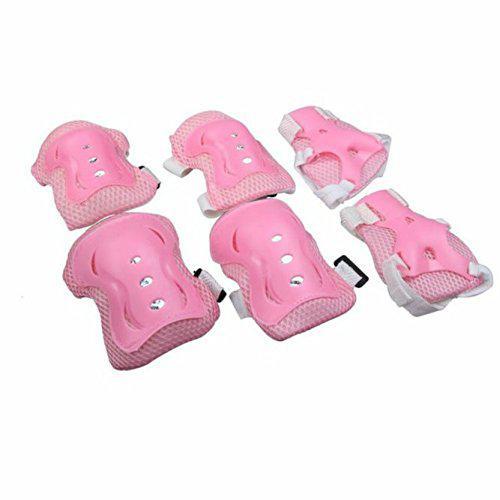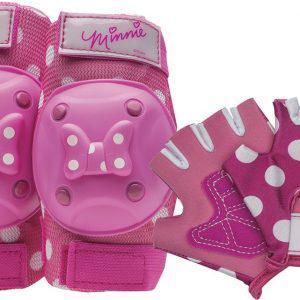The first image is the image on the left, the second image is the image on the right. Given the left and right images, does the statement "In at least one of the images, we see only knee pads; no elbow pads or gloves." hold true? Answer yes or no. No. 